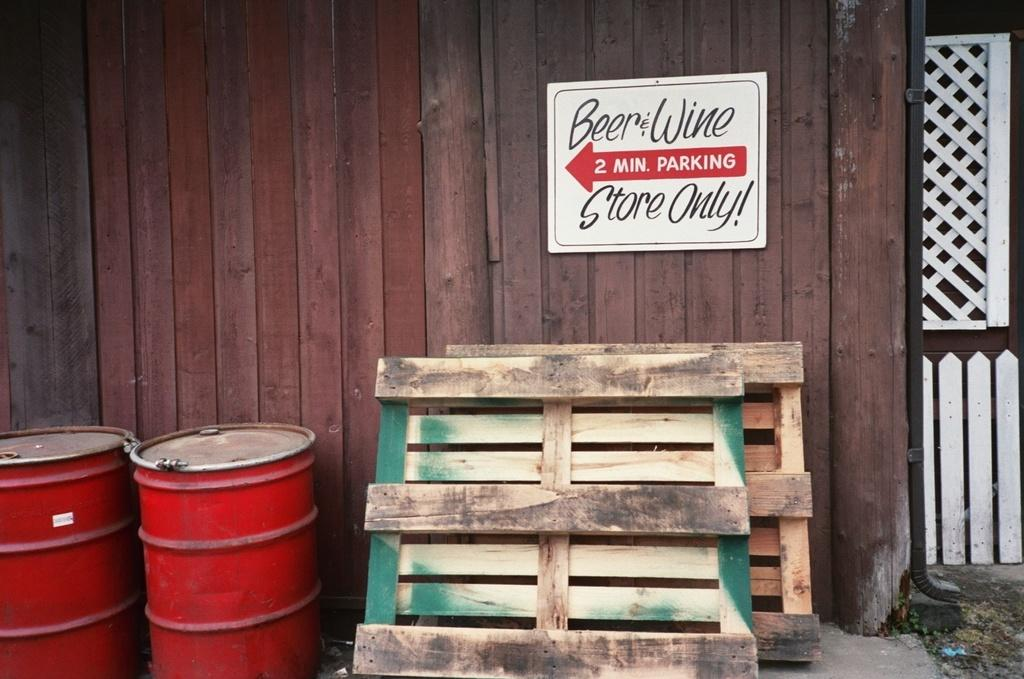What type of barrier can be seen in the image? There is a wooden fence in the image. What other man-made structures are visible in the image? There is a pipeline and an information board in the image. What objects are present that might be used for storing or transporting liquids? There are drums in the image. What material is used for the planks in the image? There are wooden planks in the image. What type of camera can be seen in the image? There is no camera present in the image. Can you see any stars in the image? There are no stars visible in the image. 